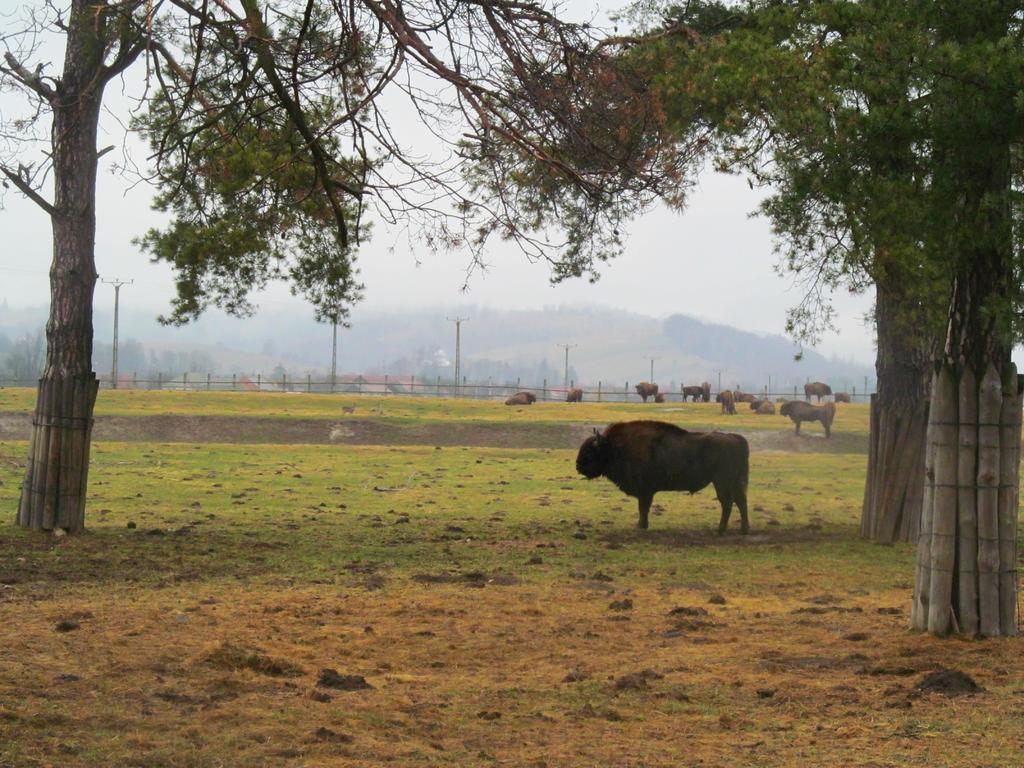What type of vegetation can be seen in the image? There are trees, plants, and grass visible in the image. What animals are present in the image? There are oxen in the image. What type of landscape is visible in the background of the image? There are mountains visible in the image. What type of birds can be seen flying over the mountains in the image? There are no birds visible in the image; it only features trees, plants, grass, oxen, and mountains. 